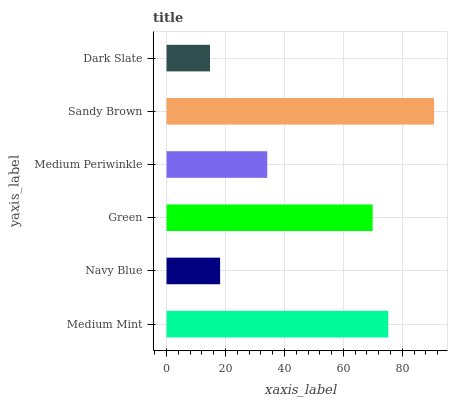Is Dark Slate the minimum?
Answer yes or no. Yes. Is Sandy Brown the maximum?
Answer yes or no. Yes. Is Navy Blue the minimum?
Answer yes or no. No. Is Navy Blue the maximum?
Answer yes or no. No. Is Medium Mint greater than Navy Blue?
Answer yes or no. Yes. Is Navy Blue less than Medium Mint?
Answer yes or no. Yes. Is Navy Blue greater than Medium Mint?
Answer yes or no. No. Is Medium Mint less than Navy Blue?
Answer yes or no. No. Is Green the high median?
Answer yes or no. Yes. Is Medium Periwinkle the low median?
Answer yes or no. Yes. Is Sandy Brown the high median?
Answer yes or no. No. Is Sandy Brown the low median?
Answer yes or no. No. 